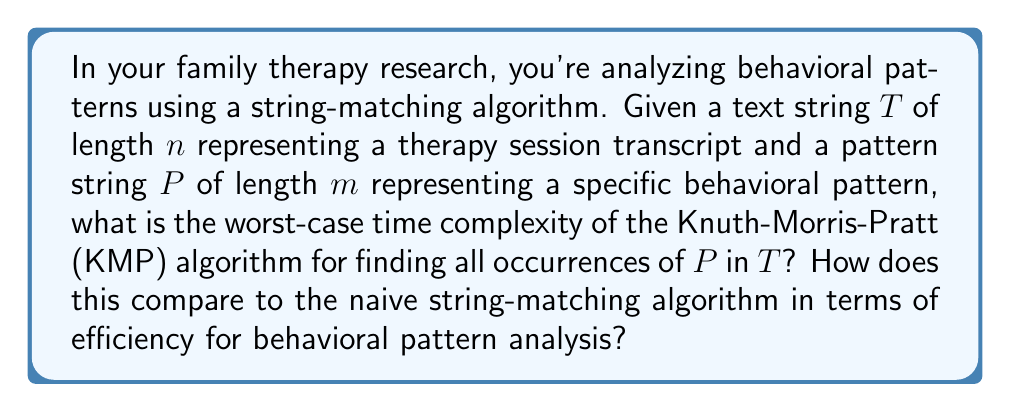Teach me how to tackle this problem. To analyze the time complexity of the Knuth-Morris-Pratt (KMP) algorithm for pattern matching in behavioral analysis data, we need to consider two main steps:

1. Preprocessing of the pattern $P$:
   The KMP algorithm first computes a failure function (also called the prefix function) for the pattern $P$. This step takes $O(m)$ time, where $m$ is the length of the pattern.

2. Searching for the pattern in the text $T$:
   The main search phase of KMP iterates through the text $T$ once, comparing characters and using the precomputed failure function to skip unnecessary comparisons. This step takes $O(n)$ time, where $n$ is the length of the text.

Therefore, the total time complexity of the KMP algorithm is:

$$O(m) + O(n) = O(m + n)$$

In the worst case, when the pattern $P$ is not found in the text $T$ or appears only at the end, the algorithm will still perform in $O(m + n)$ time.

Comparison with the naive algorithm:
The naive string-matching algorithm has a worst-case time complexity of $O(mn)$, as it may need to compare each character of the pattern with each character of the text in the worst case.

For behavioral pattern analysis in family therapy research, where the transcript (text $T$) can be very long and the behavioral pattern (pattern $P$) might be relatively short, the KMP algorithm offers significant efficiency improvements over the naive approach, especially when analyzing multiple sessions or looking for multiple patterns.

The efficiency gain becomes more pronounced as the length of the text increases, making KMP particularly suitable for analyzing large volumes of therapy session transcripts or long-term behavioral data.
Answer: The worst-case time complexity of the Knuth-Morris-Pratt (KMP) algorithm for finding all occurrences of pattern $P$ in text $T$ is $O(m + n)$, where $m$ is the length of the pattern and $n$ is the length of the text. This is significantly more efficient than the naive string-matching algorithm's worst-case time complexity of $O(mn)$, especially for large texts and multiple pattern searches common in behavioral analysis of therapy sessions. 